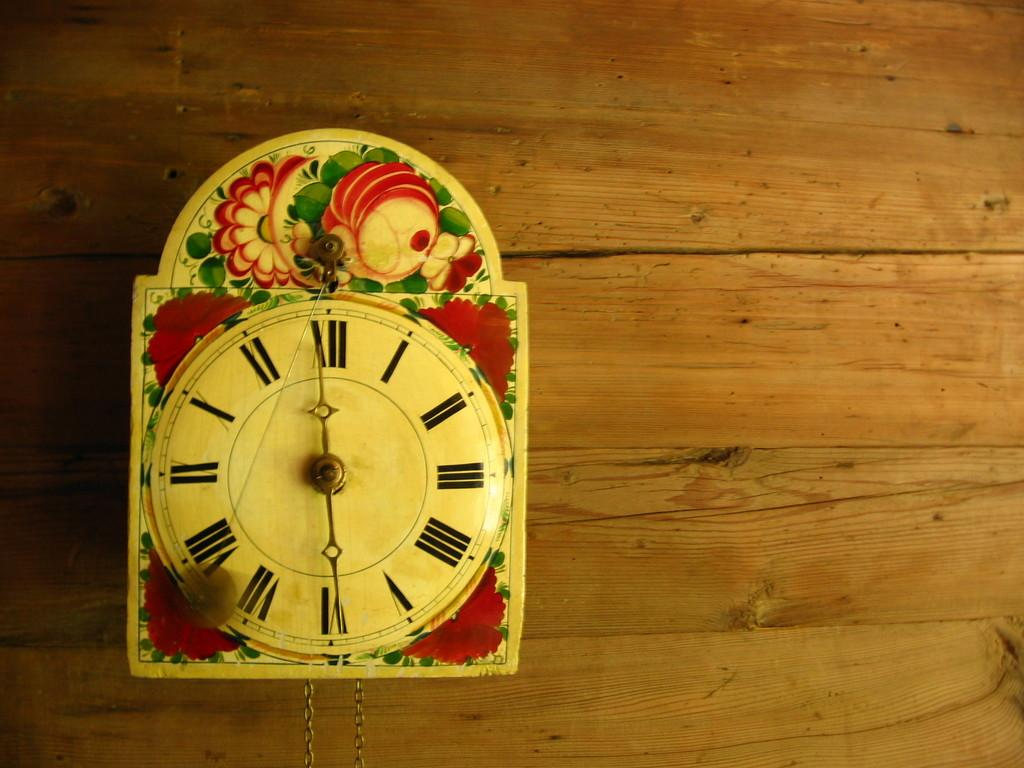<image>
Create a compact narrative representing the image presented. A clock whose hands show it is about to be six 